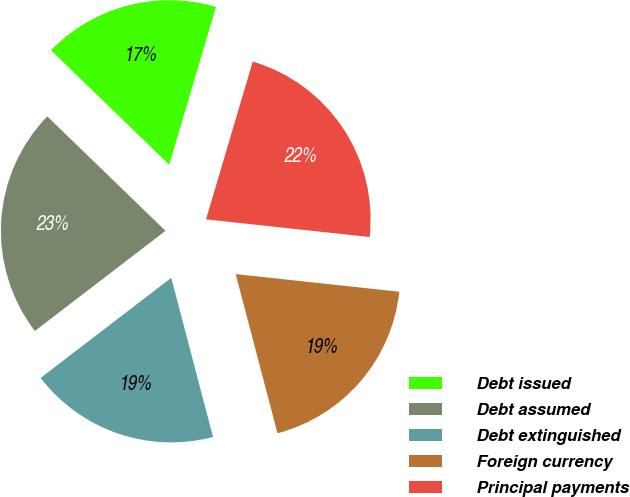<chart> <loc_0><loc_0><loc_500><loc_500><pie_chart><fcel>Debt issued<fcel>Debt assumed<fcel>Debt extinguished<fcel>Foreign currency<fcel>Principal payments<nl><fcel>17.34%<fcel>22.65%<fcel>18.68%<fcel>19.2%<fcel>22.13%<nl></chart> 